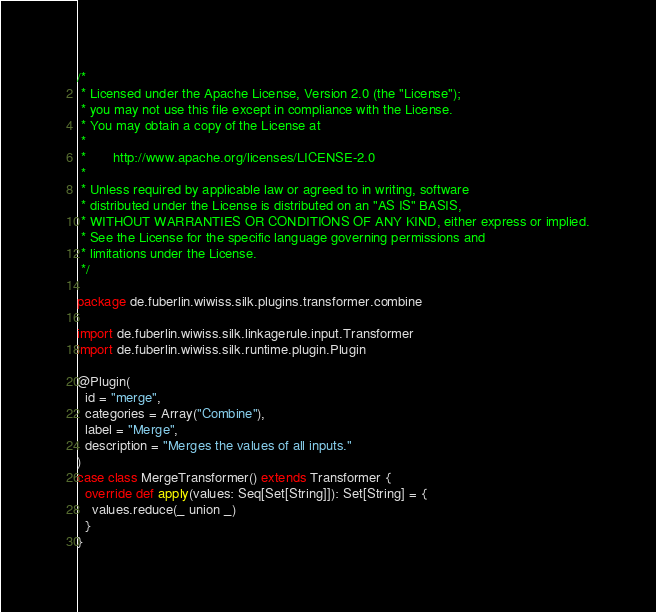Convert code to text. <code><loc_0><loc_0><loc_500><loc_500><_Scala_>/*
 * Licensed under the Apache License, Version 2.0 (the "License");
 * you may not use this file except in compliance with the License.
 * You may obtain a copy of the License at
 *
 *       http://www.apache.org/licenses/LICENSE-2.0
 *
 * Unless required by applicable law or agreed to in writing, software
 * distributed under the License is distributed on an "AS IS" BASIS,
 * WITHOUT WARRANTIES OR CONDITIONS OF ANY KIND, either express or implied.
 * See the License for the specific language governing permissions and
 * limitations under the License.
 */

package de.fuberlin.wiwiss.silk.plugins.transformer.combine

import de.fuberlin.wiwiss.silk.linkagerule.input.Transformer
import de.fuberlin.wiwiss.silk.runtime.plugin.Plugin

@Plugin(
  id = "merge",
  categories = Array("Combine"),
  label = "Merge",
  description = "Merges the values of all inputs."
)
case class MergeTransformer() extends Transformer {
  override def apply(values: Seq[Set[String]]): Set[String] = {
    values.reduce(_ union _)
  }
}</code> 